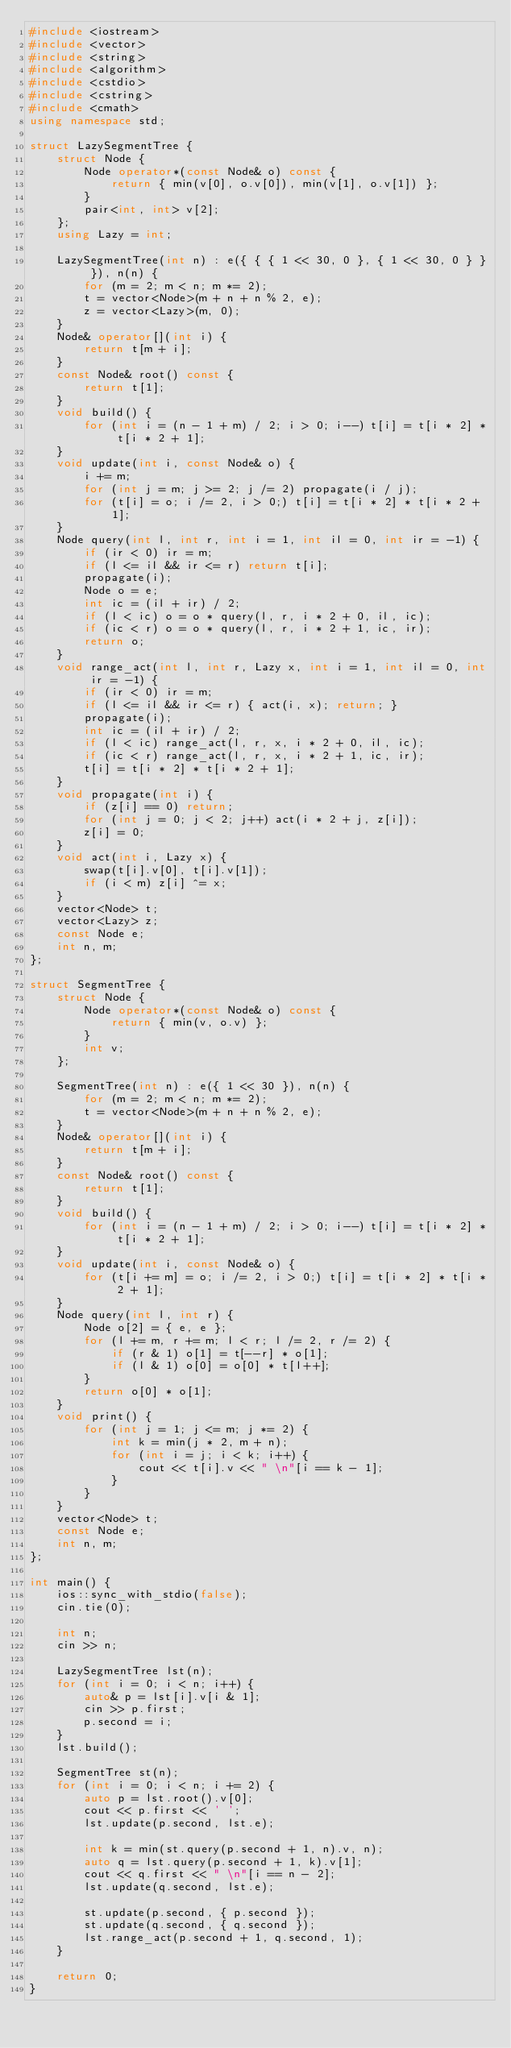Convert code to text. <code><loc_0><loc_0><loc_500><loc_500><_C++_>#include <iostream>
#include <vector>
#include <string>
#include <algorithm>
#include <cstdio>
#include <cstring>
#include <cmath>
using namespace std;

struct LazySegmentTree {
    struct Node {
        Node operator*(const Node& o) const {
            return { min(v[0], o.v[0]), min(v[1], o.v[1]) };
        }
        pair<int, int> v[2];
    };
    using Lazy = int;

    LazySegmentTree(int n) : e({ { { 1 << 30, 0 }, { 1 << 30, 0 } } }), n(n) {
        for (m = 2; m < n; m *= 2);
        t = vector<Node>(m + n + n % 2, e);
        z = vector<Lazy>(m, 0);
    }
    Node& operator[](int i) {
        return t[m + i];
    }
    const Node& root() const {
        return t[1];
    }
    void build() {
        for (int i = (n - 1 + m) / 2; i > 0; i--) t[i] = t[i * 2] * t[i * 2 + 1];
    }
    void update(int i, const Node& o) {
        i += m;
        for (int j = m; j >= 2; j /= 2) propagate(i / j);
        for (t[i] = o; i /= 2, i > 0;) t[i] = t[i * 2] * t[i * 2 + 1];
    }
    Node query(int l, int r, int i = 1, int il = 0, int ir = -1) {
        if (ir < 0) ir = m;
        if (l <= il && ir <= r) return t[i];
        propagate(i);
        Node o = e;
        int ic = (il + ir) / 2;
        if (l < ic) o = o * query(l, r, i * 2 + 0, il, ic);
        if (ic < r) o = o * query(l, r, i * 2 + 1, ic, ir);
        return o;
    }
    void range_act(int l, int r, Lazy x, int i = 1, int il = 0, int ir = -1) { 
        if (ir < 0) ir = m;
        if (l <= il && ir <= r) { act(i, x); return; }
        propagate(i);
        int ic = (il + ir) / 2;
        if (l < ic) range_act(l, r, x, i * 2 + 0, il, ic);
        if (ic < r) range_act(l, r, x, i * 2 + 1, ic, ir);
        t[i] = t[i * 2] * t[i * 2 + 1];
    }
    void propagate(int i) {
        if (z[i] == 0) return;
        for (int j = 0; j < 2; j++) act(i * 2 + j, z[i]);
        z[i] = 0;
    }
    void act(int i, Lazy x) {
        swap(t[i].v[0], t[i].v[1]);
        if (i < m) z[i] ^= x;
    }
    vector<Node> t;
    vector<Lazy> z;
    const Node e;
    int n, m;
};

struct SegmentTree {
    struct Node {
        Node operator*(const Node& o) const {
            return { min(v, o.v) };
        }
        int v;
    };

    SegmentTree(int n) : e({ 1 << 30 }), n(n) {
        for (m = 2; m < n; m *= 2);
        t = vector<Node>(m + n + n % 2, e);
    }
    Node& operator[](int i) {
        return t[m + i];
    }
    const Node& root() const {
        return t[1];
    }
    void build() {
        for (int i = (n - 1 + m) / 2; i > 0; i--) t[i] = t[i * 2] * t[i * 2 + 1];
    }
    void update(int i, const Node& o) {
        for (t[i += m] = o; i /= 2, i > 0;) t[i] = t[i * 2] * t[i * 2 + 1];
    }
    Node query(int l, int r) {
        Node o[2] = { e, e };
        for (l += m, r += m; l < r; l /= 2, r /= 2) {
            if (r & 1) o[1] = t[--r] * o[1];
            if (l & 1) o[0] = o[0] * t[l++];
        }
        return o[0] * o[1];
    }
    void print() {
        for (int j = 1; j <= m; j *= 2) {
            int k = min(j * 2, m + n);
            for (int i = j; i < k; i++) {
                cout << t[i].v << " \n"[i == k - 1];
            }
        }
    }
    vector<Node> t;
    const Node e;
    int n, m;
};

int main() {
    ios::sync_with_stdio(false);
    cin.tie(0);

    int n;
    cin >> n;

    LazySegmentTree lst(n);
    for (int i = 0; i < n; i++) {
        auto& p = lst[i].v[i & 1];
        cin >> p.first;
        p.second = i;
    }
    lst.build();

    SegmentTree st(n);
    for (int i = 0; i < n; i += 2) {
        auto p = lst.root().v[0];
        cout << p.first << ' ';
        lst.update(p.second, lst.e);

        int k = min(st.query(p.second + 1, n).v, n);
        auto q = lst.query(p.second + 1, k).v[1];
        cout << q.first << " \n"[i == n - 2];
        lst.update(q.second, lst.e);

        st.update(p.second, { p.second });
        st.update(q.second, { q.second });
        lst.range_act(p.second + 1, q.second, 1);
    }

    return 0;
}</code> 